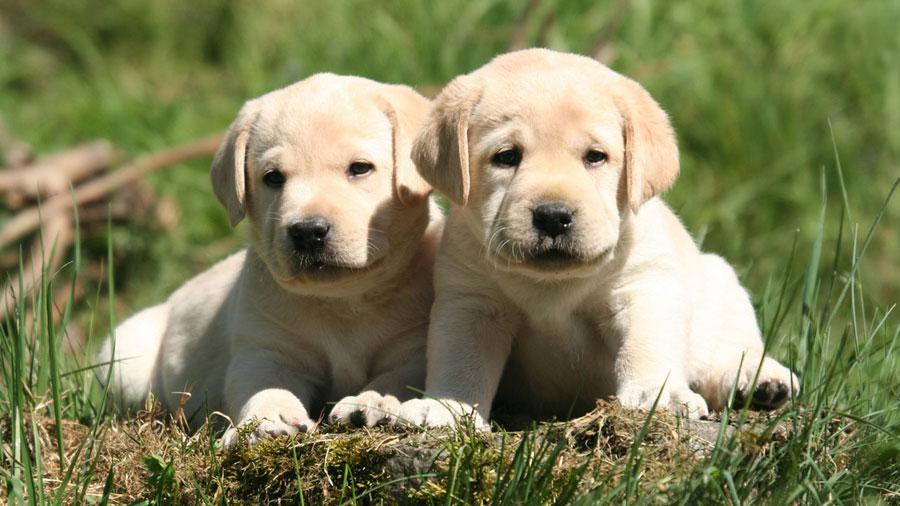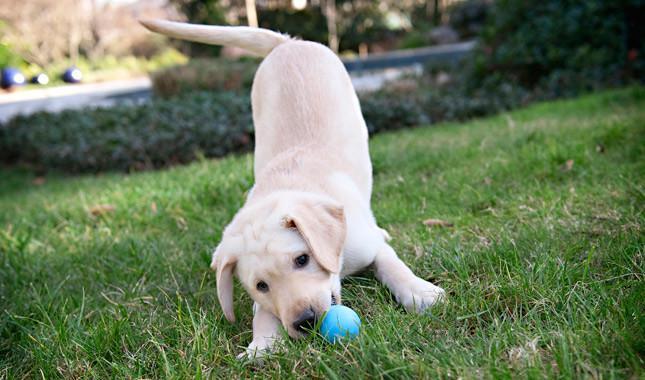The first image is the image on the left, the second image is the image on the right. Considering the images on both sides, is "An image shows one dog in the grass with a ball." valid? Answer yes or no. Yes. The first image is the image on the left, the second image is the image on the right. Analyze the images presented: Is the assertion "A ball sits on the grass in front of one of the dogs." valid? Answer yes or no. Yes. 